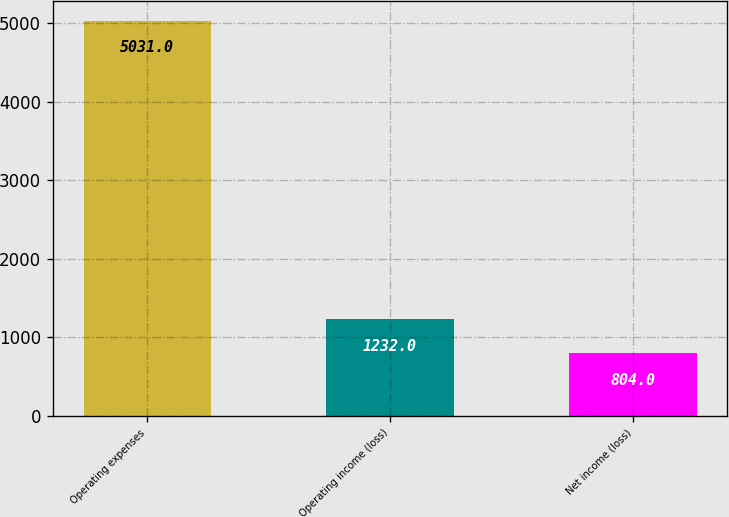<chart> <loc_0><loc_0><loc_500><loc_500><bar_chart><fcel>Operating expenses<fcel>Operating income (loss)<fcel>Net income (loss)<nl><fcel>5031<fcel>1232<fcel>804<nl></chart> 